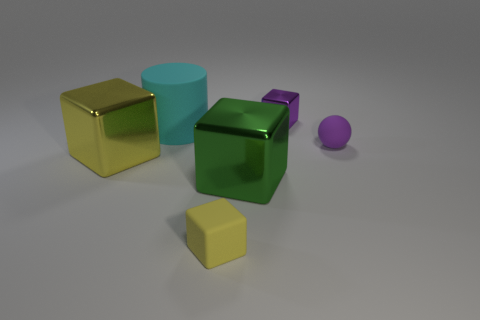Does the small purple matte object have the same shape as the large green metal object?
Offer a very short reply. No. Are there any big yellow shiny things that have the same shape as the large rubber object?
Offer a terse response. No. There is a yellow thing to the left of the tiny yellow matte block that is to the left of the large green metal block; what shape is it?
Offer a terse response. Cube. What color is the big block that is behind the large green metal block?
Your answer should be very brief. Yellow. What is the size of the green cube that is the same material as the large yellow object?
Your answer should be compact. Large. There is a purple shiny object that is the same shape as the big green metallic object; what size is it?
Make the answer very short. Small. Is there a yellow metallic thing?
Your answer should be very brief. Yes. How many objects are either large shiny objects on the right side of the big yellow metal thing or small metal things?
Offer a very short reply. 2. There is a cyan object that is the same size as the yellow metal object; what material is it?
Offer a very short reply. Rubber. There is a rubber thing that is in front of the small matte thing that is on the right side of the purple metallic block; what is its color?
Keep it short and to the point. Yellow. 